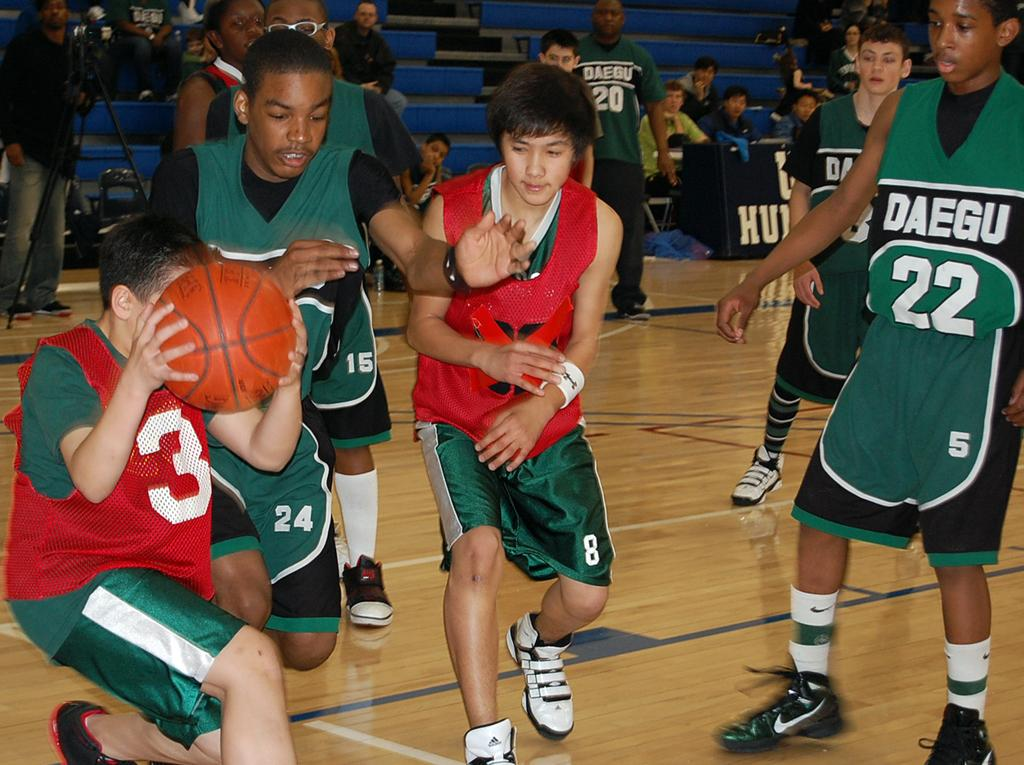What is the main setting of the image? The main setting of the image is a playground. Who can be seen in the playground? There are persons in the playground. Can you describe the people in the background of the image? There is an audience in the backdrop. What type of wire is being used by the girls in the image? There are no girls or wire present in the image. What appliance is being used by the audience in the image? There is no appliance mentioned or visible in the image. 